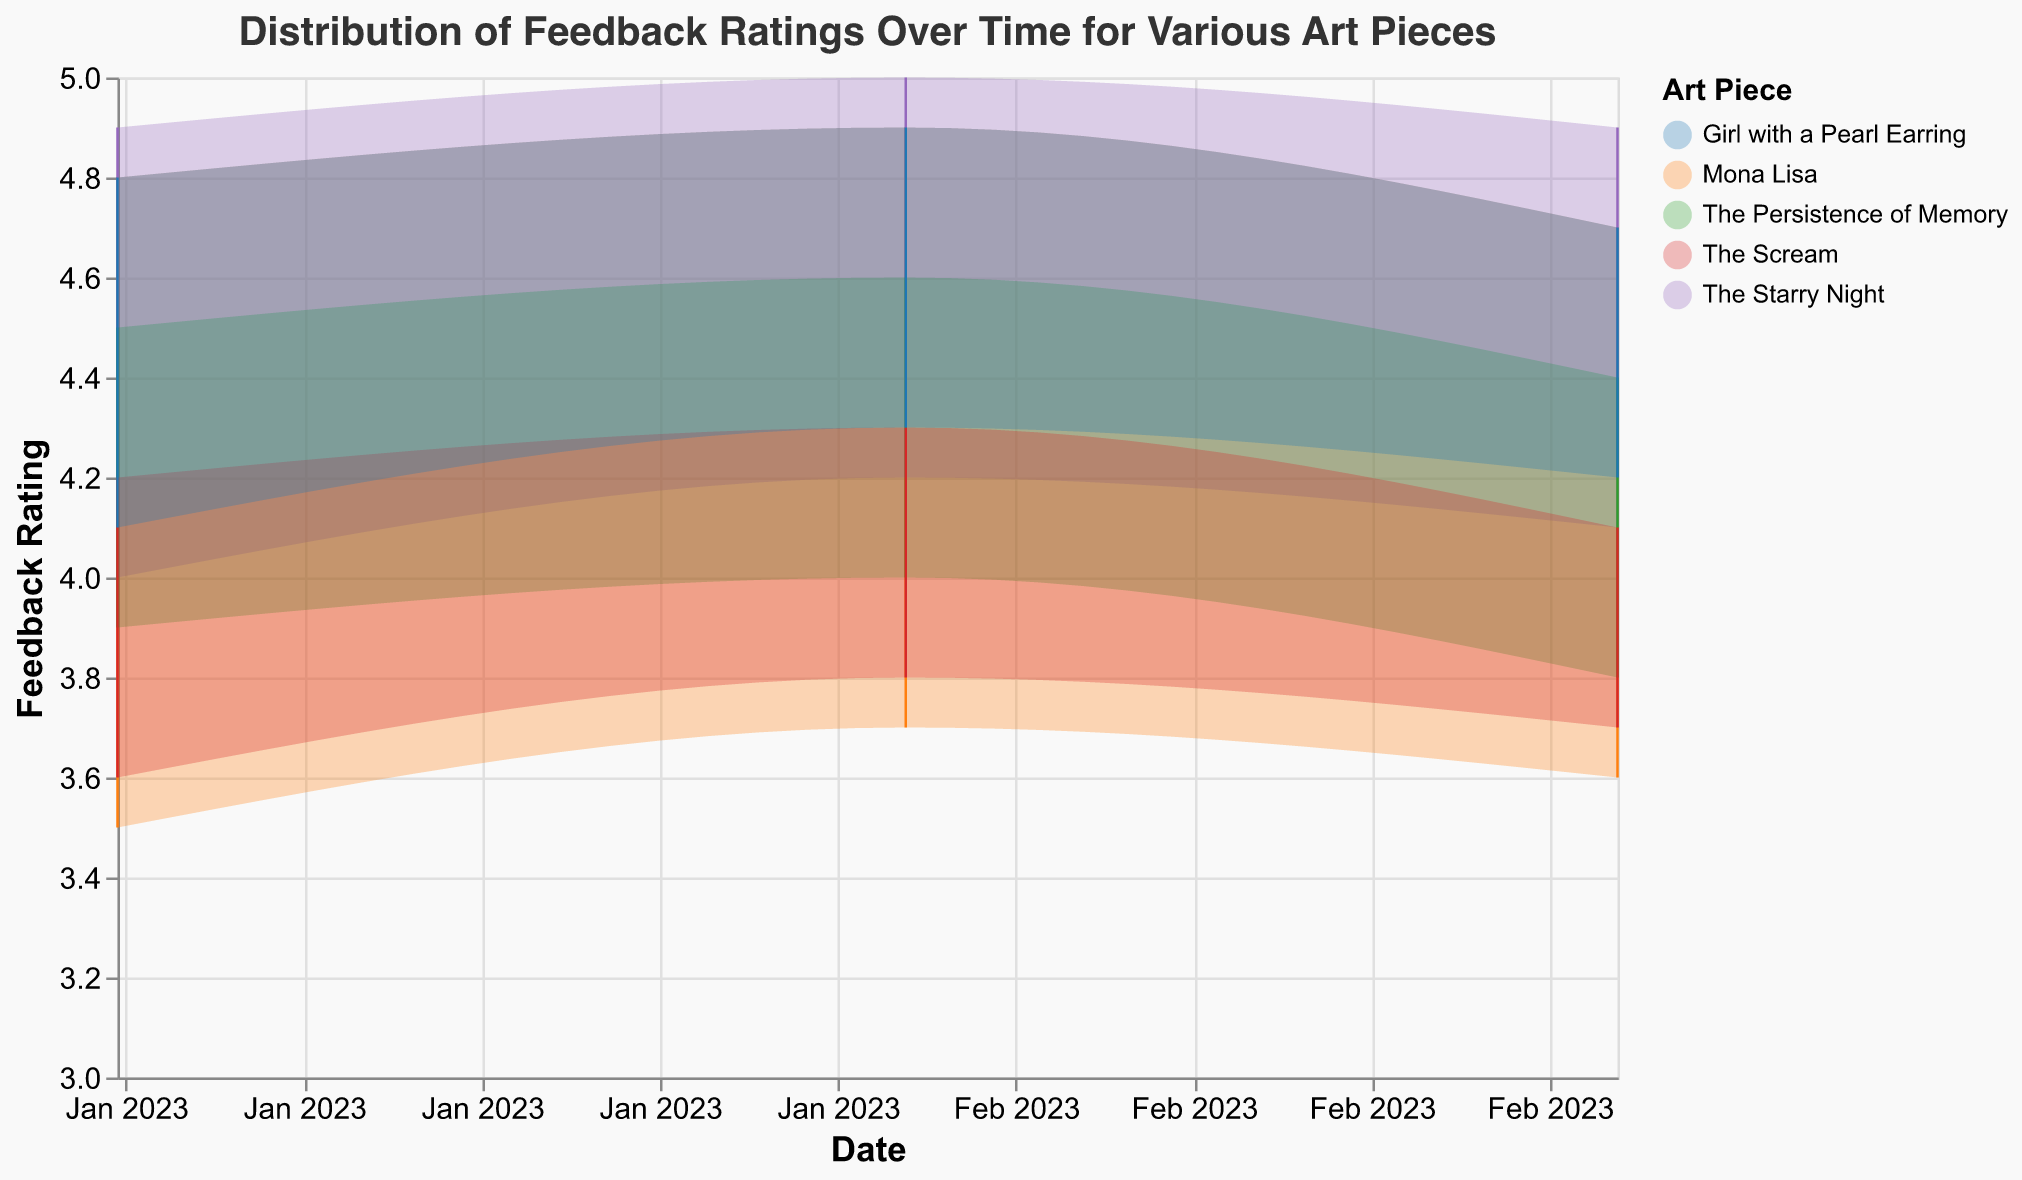What is the title of the range area chart? The title of the chart is displayed at the top of the figure, providing context for what the chart represents.
Answer: Distribution of Feedback Ratings Over Time for Various Art Pieces What are the date ranges shown on the x-axis? The x-axis represents time, with specific dates displayed. By examining the axis labels, one can see the range covered by the data.
Answer: January 2023 to March 2023 Which art piece has the highest maximum feedback rating in February 2023? To find this, look for February 2023 data points and identify which art piece has the highest maximum feedback rating marked on the y-axis.
Answer: The Starry Night Which art piece has the narrowest range of feedback ratings in January 2023? The range of feedback ratings is represented by the area between the minimum and maximum ratings. By observing this area for January 2023, we can identify the narrowest range.
Answer: The Starry Night How did 'The Scream' feedback ratings change from January to March 2023? This question requires a comparison of 'The Scream' feedback ratings across three months. By looking at the plotted data points for 'The Scream', we note any changes in its rating range.
Answer: The minimum rating increased slightly from 3.6 to 3.7, while the maximum decreased from 4.2 to 4.1 Which art piece shows the most consistent feedback rating over the three months? Consistency in feedback ratings can be seen by identifying an art piece with minimal changes in both minimum and maximum feedback ratings across the months.
Answer: Girl with a Pearl Earring What is the average max feedback rating for 'Mona Lisa' over the three months? Calculate the average of the maximum ratings for 'Mona Lisa' in January, February, and March by summing these values and dividing by three. Step by step: (4.8 + 4.9 + 4.7)/3 = 14.4/3 = 4.8
Answer: 4.8 Which month had the highest overall range of feedback ratings across all art pieces? To determine this, compare the range (max - min) of feedback ratings for all art pieces for each month, and determine which month had the highest values collectively.
Answer: February 2023 Did 'The Persistence of Memory' experience an increase or decrease in its minimum feedback rating from February to March 2023? Compare 'The Persistence of Memory' minimum feedback ratings from February (4.0) to March (3.8) using the y-axis values.
Answer: Decrease Which two art pieces had the highest overlap in feedback rating ranges in March 2023? To find the highest overlap, observe the areas (y to y2 coordinates) visually in March 2023 and identify the art pieces with the most similar ranges.
Answer: Mona Lisa and The Starry Night 